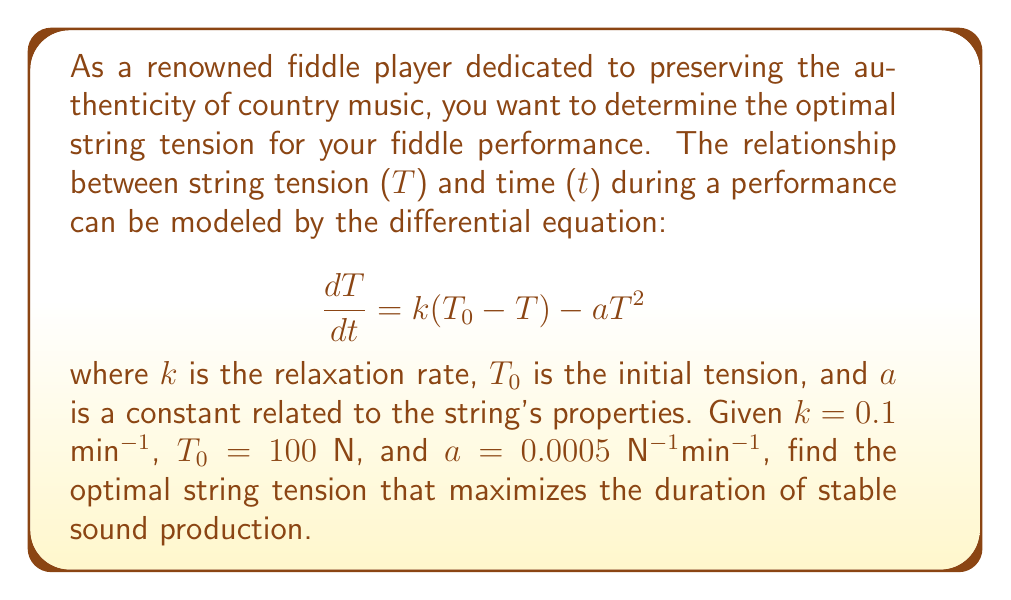Can you solve this math problem? To find the optimal string tension, we need to determine the equilibrium point of the differential equation. At equilibrium, the rate of change of tension is zero:

$$\frac{dT}{dt} = 0$$

Substituting this into our original equation:

$$0 = k(T_0 - T) - aT^2$$

Rearranging the terms:

$$aT^2 + kT - kT_0 = 0$$

This is a quadratic equation in the form $ax^2 + bx + c = 0$. We can solve it using the quadratic formula:

$$T = \frac{-b \pm \sqrt{b^2 - 4ac}}{2a}$$

Where $a = 0.0005$, $b = k = 0.1$, and $c = -kT_0 = -10$

Substituting these values:

$$T = \frac{-0.1 \pm \sqrt{0.1^2 - 4(0.0005)(-10)}}{2(0.0005)}$$

$$T = \frac{-0.1 \pm \sqrt{0.01 + 0.02}}{0.001}$$

$$T = \frac{-0.1 \pm \sqrt{0.03}}{0.001}$$

$$T = \frac{-0.1 \pm 0.1732}{0.001}$$

This gives us two solutions:

$$T_1 = \frac{-0.1 + 0.1732}{0.001} = 73.2 \text{ N}$$

$$T_2 = \frac{-0.1 - 0.1732}{0.001} = -273.2 \text{ N}$$

Since tension cannot be negative, we discard the second solution. Therefore, the optimal string tension is approximately 73.2 N.
Answer: 73.2 N 